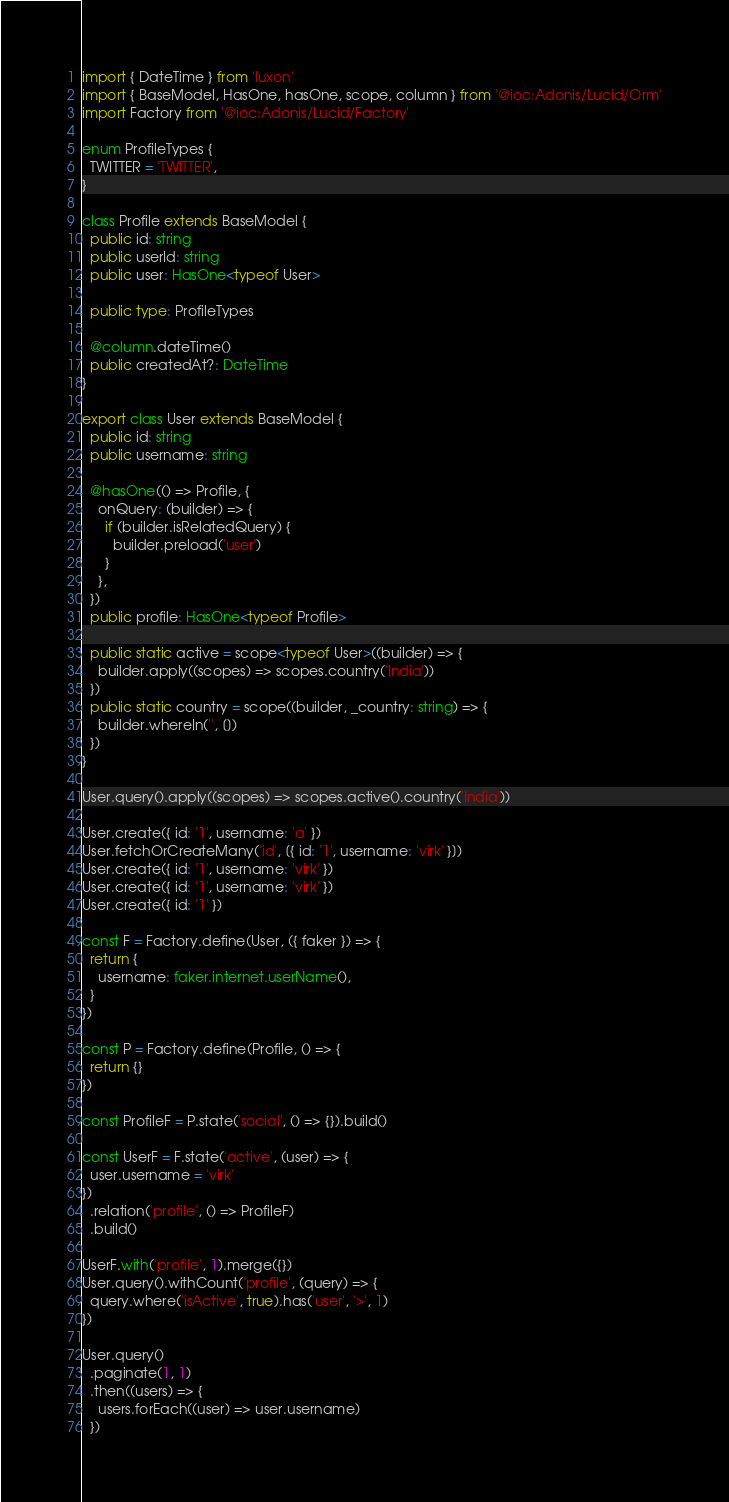<code> <loc_0><loc_0><loc_500><loc_500><_TypeScript_>import { DateTime } from 'luxon'
import { BaseModel, HasOne, hasOne, scope, column } from '@ioc:Adonis/Lucid/Orm'
import Factory from '@ioc:Adonis/Lucid/Factory'

enum ProfileTypes {
  TWITTER = 'TWITTER',
}

class Profile extends BaseModel {
  public id: string
  public userId: string
  public user: HasOne<typeof User>

  public type: ProfileTypes

  @column.dateTime()
  public createdAt?: DateTime
}

export class User extends BaseModel {
  public id: string
  public username: string

  @hasOne(() => Profile, {
    onQuery: (builder) => {
      if (builder.isRelatedQuery) {
        builder.preload('user')
      }
    },
  })
  public profile: HasOne<typeof Profile>

  public static active = scope<typeof User>((builder) => {
    builder.apply((scopes) => scopes.country('India'))
  })
  public static country = scope((builder, _country: string) => {
    builder.whereIn('', [])
  })
}

User.query().apply((scopes) => scopes.active().country('India'))

User.create({ id: '1', username: 'a' })
User.fetchOrCreateMany('id', [{ id: '1', username: 'virk' }])
User.create({ id: '1', username: 'virk' })
User.create({ id: '1', username: 'virk' })
User.create({ id: '1' })

const F = Factory.define(User, ({ faker }) => {
  return {
    username: faker.internet.userName(),
  }
})

const P = Factory.define(Profile, () => {
  return {}
})

const ProfileF = P.state('social', () => {}).build()

const UserF = F.state('active', (user) => {
  user.username = 'virk'
})
  .relation('profile', () => ProfileF)
  .build()

UserF.with('profile', 1).merge({})
User.query().withCount('profile', (query) => {
  query.where('isActive', true).has('user', '>', 1)
})

User.query()
  .paginate(1, 1)
  .then((users) => {
    users.forEach((user) => user.username)
  })
</code> 